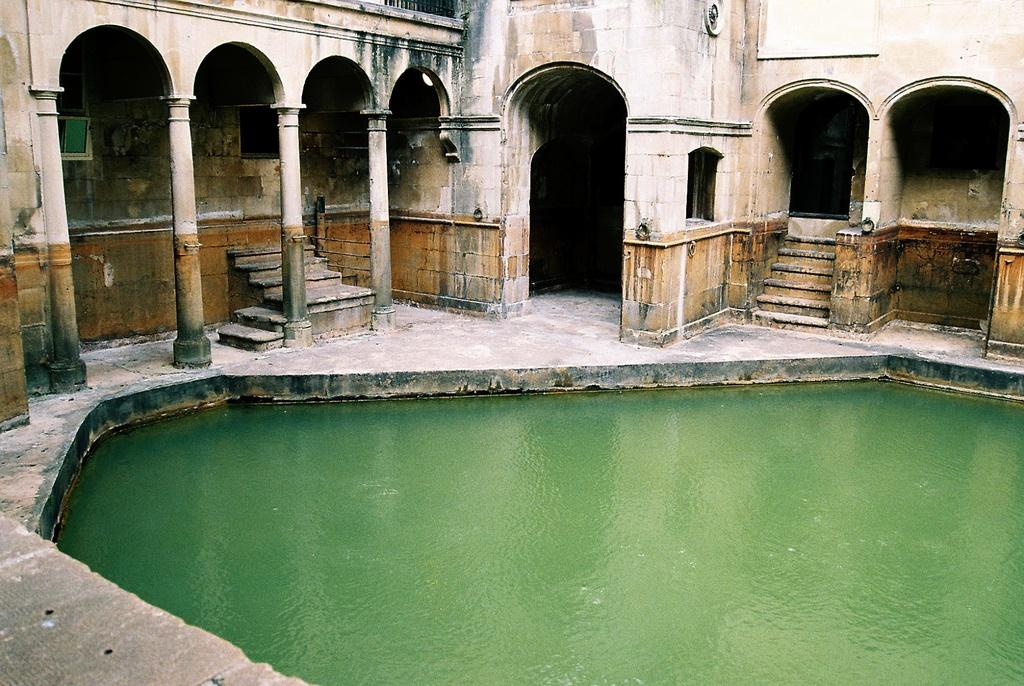What type of water body is present in the image? There is a pond in the image. What architectural features can be seen in the image? There are pillars, stairs, walls, and an entrance visible in the image. What type of sock is hanging on the pillar in the image? There is no sock present in the image; it only features a pond and architectural elements. 